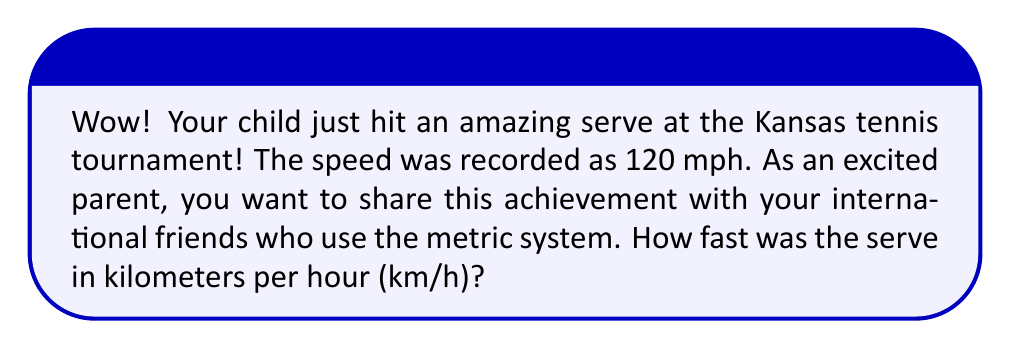Teach me how to tackle this problem. Let's convert the serve speed from miles per hour (mph) to kilometers per hour (km/h) step by step:

1. First, recall the conversion factor:
   1 mile ≈ 1.60934 kilometers

2. Set up the conversion equation:
   $$ 120 \text{ mph} \times \frac{1.60934 \text{ km}}{1 \text{ mile}} = x \text{ km/h} $$

3. Multiply the numbers:
   $$ x = 120 \times 1.60934 = 193.1208 \text{ km/h} $$

4. Round to a reasonable number of decimal places (let's use 1):
   $$ x ≈ 193.1 \text{ km/h} $$

Therefore, the serve speed of 120 mph is approximately 193.1 km/h.
Answer: 193.1 km/h 